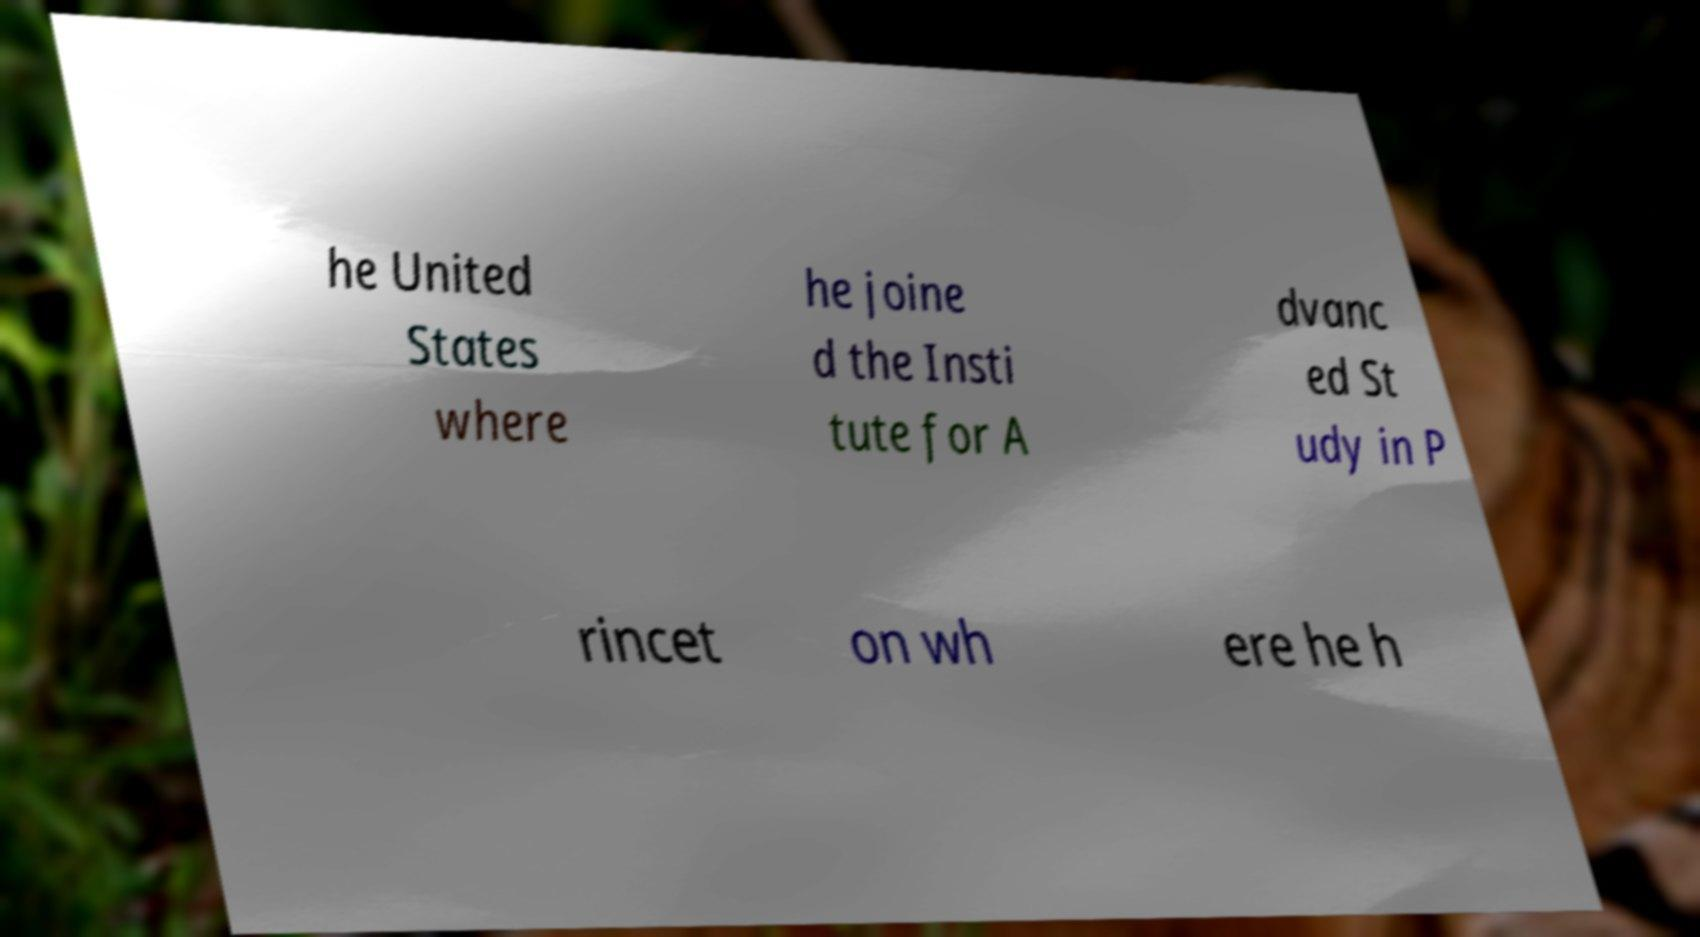Can you accurately transcribe the text from the provided image for me? he United States where he joine d the Insti tute for A dvanc ed St udy in P rincet on wh ere he h 